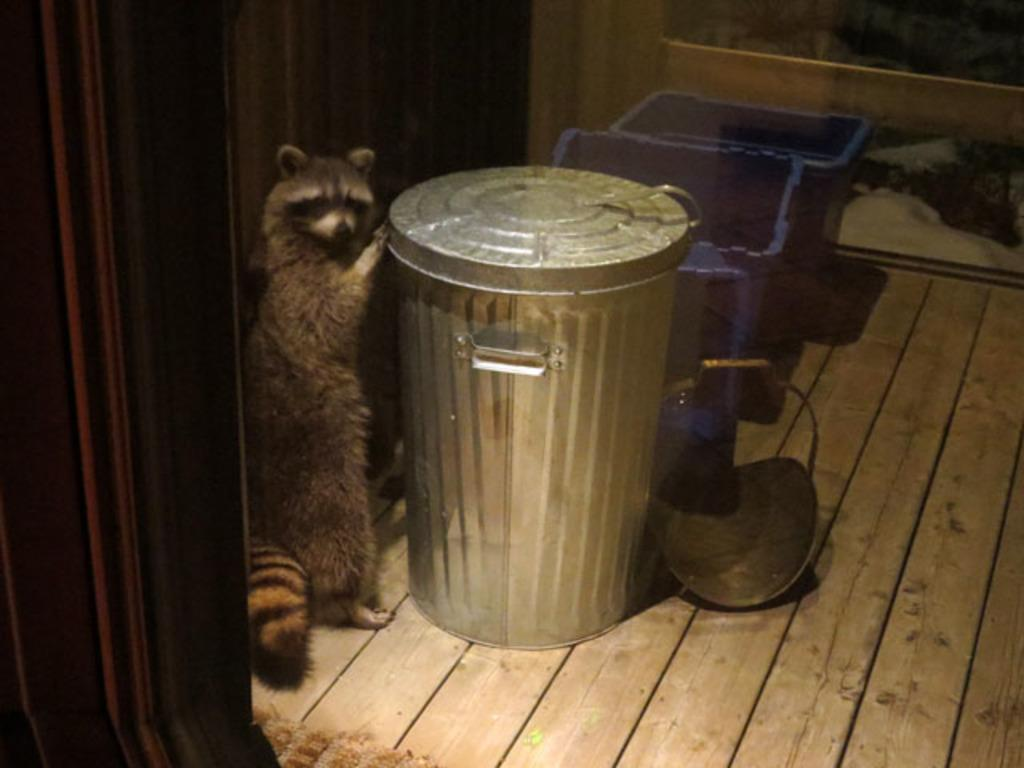What type of creature is in the image? There is an animal in the image. Where is the animal located in the image? The animal is standing on the floor. What is the animal holding in the image? The animal is holding a bin. What type of branch is the animal sitting on during the meeting in the image? There is no branch or meeting present in the image; the animal is standing on the floor and holding a bin. 